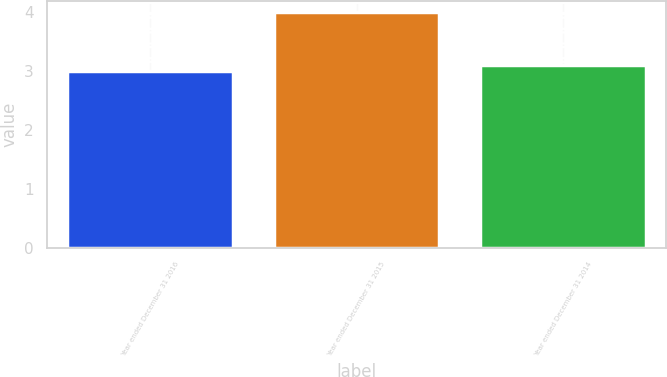Convert chart to OTSL. <chart><loc_0><loc_0><loc_500><loc_500><bar_chart><fcel>Year ended December 31 2016<fcel>Year ended December 31 2015<fcel>Year ended December 31 2014<nl><fcel>3<fcel>4<fcel>3.1<nl></chart> 